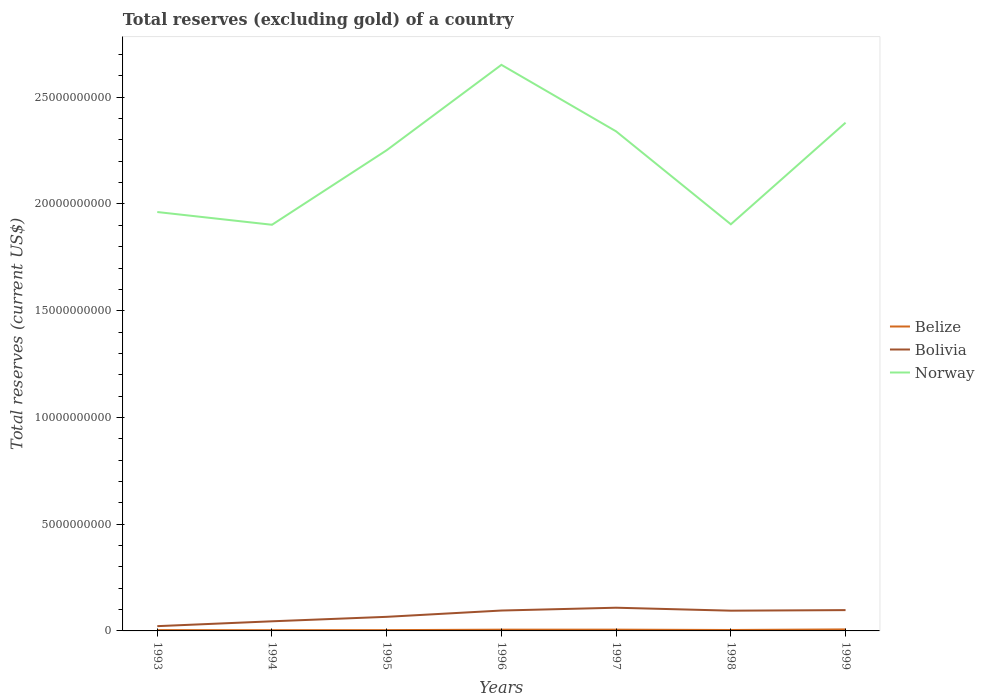Does the line corresponding to Belize intersect with the line corresponding to Bolivia?
Your answer should be very brief. No. Is the number of lines equal to the number of legend labels?
Offer a very short reply. Yes. Across all years, what is the maximum total reserves (excluding gold) in Belize?
Provide a succinct answer. 3.45e+07. What is the total total reserves (excluding gold) in Norway in the graph?
Provide a short and direct response. -8.83e+08. What is the difference between the highest and the second highest total reserves (excluding gold) in Norway?
Offer a very short reply. 7.49e+09. Is the total reserves (excluding gold) in Bolivia strictly greater than the total reserves (excluding gold) in Norway over the years?
Your answer should be very brief. Yes. What is the difference between two consecutive major ticks on the Y-axis?
Make the answer very short. 5.00e+09. How many legend labels are there?
Make the answer very short. 3. How are the legend labels stacked?
Give a very brief answer. Vertical. What is the title of the graph?
Give a very brief answer. Total reserves (excluding gold) of a country. What is the label or title of the Y-axis?
Give a very brief answer. Total reserves (current US$). What is the Total reserves (current US$) in Belize in 1993?
Keep it short and to the point. 3.87e+07. What is the Total reserves (current US$) in Bolivia in 1993?
Keep it short and to the point. 2.23e+08. What is the Total reserves (current US$) of Norway in 1993?
Provide a succinct answer. 1.96e+1. What is the Total reserves (current US$) in Belize in 1994?
Provide a succinct answer. 3.45e+07. What is the Total reserves (current US$) in Bolivia in 1994?
Make the answer very short. 4.51e+08. What is the Total reserves (current US$) of Norway in 1994?
Your answer should be very brief. 1.90e+1. What is the Total reserves (current US$) of Belize in 1995?
Ensure brevity in your answer.  3.76e+07. What is the Total reserves (current US$) of Bolivia in 1995?
Offer a very short reply. 6.60e+08. What is the Total reserves (current US$) in Norway in 1995?
Keep it short and to the point. 2.25e+1. What is the Total reserves (current US$) of Belize in 1996?
Provide a succinct answer. 5.84e+07. What is the Total reserves (current US$) in Bolivia in 1996?
Ensure brevity in your answer.  9.55e+08. What is the Total reserves (current US$) of Norway in 1996?
Offer a terse response. 2.65e+1. What is the Total reserves (current US$) in Belize in 1997?
Provide a short and direct response. 5.94e+07. What is the Total reserves (current US$) in Bolivia in 1997?
Your response must be concise. 1.09e+09. What is the Total reserves (current US$) in Norway in 1997?
Your answer should be compact. 2.34e+1. What is the Total reserves (current US$) in Belize in 1998?
Your answer should be very brief. 4.41e+07. What is the Total reserves (current US$) of Bolivia in 1998?
Offer a very short reply. 9.48e+08. What is the Total reserves (current US$) in Norway in 1998?
Ensure brevity in your answer.  1.90e+1. What is the Total reserves (current US$) in Belize in 1999?
Your answer should be compact. 7.13e+07. What is the Total reserves (current US$) in Bolivia in 1999?
Provide a succinct answer. 9.75e+08. What is the Total reserves (current US$) of Norway in 1999?
Make the answer very short. 2.38e+1. Across all years, what is the maximum Total reserves (current US$) of Belize?
Your answer should be compact. 7.13e+07. Across all years, what is the maximum Total reserves (current US$) of Bolivia?
Make the answer very short. 1.09e+09. Across all years, what is the maximum Total reserves (current US$) in Norway?
Make the answer very short. 2.65e+1. Across all years, what is the minimum Total reserves (current US$) in Belize?
Ensure brevity in your answer.  3.45e+07. Across all years, what is the minimum Total reserves (current US$) of Bolivia?
Offer a very short reply. 2.23e+08. Across all years, what is the minimum Total reserves (current US$) in Norway?
Offer a terse response. 1.90e+1. What is the total Total reserves (current US$) of Belize in the graph?
Provide a short and direct response. 3.44e+08. What is the total Total reserves (current US$) in Bolivia in the graph?
Your answer should be compact. 5.30e+09. What is the total Total reserves (current US$) in Norway in the graph?
Provide a short and direct response. 1.54e+11. What is the difference between the Total reserves (current US$) of Belize in 1993 and that in 1994?
Provide a succinct answer. 4.22e+06. What is the difference between the Total reserves (current US$) in Bolivia in 1993 and that in 1994?
Your response must be concise. -2.28e+08. What is the difference between the Total reserves (current US$) of Norway in 1993 and that in 1994?
Provide a succinct answer. 5.97e+08. What is the difference between the Total reserves (current US$) in Belize in 1993 and that in 1995?
Provide a succinct answer. 1.14e+06. What is the difference between the Total reserves (current US$) in Bolivia in 1993 and that in 1995?
Your response must be concise. -4.37e+08. What is the difference between the Total reserves (current US$) of Norway in 1993 and that in 1995?
Your answer should be compact. -2.90e+09. What is the difference between the Total reserves (current US$) in Belize in 1993 and that in 1996?
Keep it short and to the point. -1.97e+07. What is the difference between the Total reserves (current US$) in Bolivia in 1993 and that in 1996?
Give a very brief answer. -7.32e+08. What is the difference between the Total reserves (current US$) of Norway in 1993 and that in 1996?
Make the answer very short. -6.89e+09. What is the difference between the Total reserves (current US$) of Belize in 1993 and that in 1997?
Offer a terse response. -2.07e+07. What is the difference between the Total reserves (current US$) in Bolivia in 1993 and that in 1997?
Offer a terse response. -8.63e+08. What is the difference between the Total reserves (current US$) of Norway in 1993 and that in 1997?
Your answer should be compact. -3.78e+09. What is the difference between the Total reserves (current US$) in Belize in 1993 and that in 1998?
Provide a succinct answer. -5.34e+06. What is the difference between the Total reserves (current US$) in Bolivia in 1993 and that in 1998?
Keep it short and to the point. -7.25e+08. What is the difference between the Total reserves (current US$) in Norway in 1993 and that in 1998?
Ensure brevity in your answer.  5.74e+08. What is the difference between the Total reserves (current US$) in Belize in 1993 and that in 1999?
Your answer should be compact. -3.26e+07. What is the difference between the Total reserves (current US$) of Bolivia in 1993 and that in 1999?
Your answer should be compact. -7.52e+08. What is the difference between the Total reserves (current US$) in Norway in 1993 and that in 1999?
Give a very brief answer. -4.18e+09. What is the difference between the Total reserves (current US$) of Belize in 1994 and that in 1995?
Provide a succinct answer. -3.09e+06. What is the difference between the Total reserves (current US$) in Bolivia in 1994 and that in 1995?
Your answer should be very brief. -2.09e+08. What is the difference between the Total reserves (current US$) of Norway in 1994 and that in 1995?
Give a very brief answer. -3.49e+09. What is the difference between the Total reserves (current US$) of Belize in 1994 and that in 1996?
Offer a very short reply. -2.39e+07. What is the difference between the Total reserves (current US$) in Bolivia in 1994 and that in 1996?
Your answer should be very brief. -5.04e+08. What is the difference between the Total reserves (current US$) in Norway in 1994 and that in 1996?
Make the answer very short. -7.49e+09. What is the difference between the Total reserves (current US$) in Belize in 1994 and that in 1997?
Keep it short and to the point. -2.49e+07. What is the difference between the Total reserves (current US$) of Bolivia in 1994 and that in 1997?
Offer a very short reply. -6.36e+08. What is the difference between the Total reserves (current US$) of Norway in 1994 and that in 1997?
Provide a short and direct response. -4.37e+09. What is the difference between the Total reserves (current US$) of Belize in 1994 and that in 1998?
Your response must be concise. -9.56e+06. What is the difference between the Total reserves (current US$) of Bolivia in 1994 and that in 1998?
Your response must be concise. -4.98e+08. What is the difference between the Total reserves (current US$) in Norway in 1994 and that in 1998?
Offer a very short reply. -2.26e+07. What is the difference between the Total reserves (current US$) in Belize in 1994 and that in 1999?
Offer a very short reply. -3.68e+07. What is the difference between the Total reserves (current US$) in Bolivia in 1994 and that in 1999?
Make the answer very short. -5.24e+08. What is the difference between the Total reserves (current US$) of Norway in 1994 and that in 1999?
Ensure brevity in your answer.  -4.78e+09. What is the difference between the Total reserves (current US$) in Belize in 1995 and that in 1996?
Your answer should be compact. -2.08e+07. What is the difference between the Total reserves (current US$) of Bolivia in 1995 and that in 1996?
Give a very brief answer. -2.95e+08. What is the difference between the Total reserves (current US$) of Norway in 1995 and that in 1996?
Make the answer very short. -4.00e+09. What is the difference between the Total reserves (current US$) in Belize in 1995 and that in 1997?
Your answer should be compact. -2.18e+07. What is the difference between the Total reserves (current US$) in Bolivia in 1995 and that in 1997?
Your response must be concise. -4.27e+08. What is the difference between the Total reserves (current US$) in Norway in 1995 and that in 1997?
Your response must be concise. -8.83e+08. What is the difference between the Total reserves (current US$) in Belize in 1995 and that in 1998?
Ensure brevity in your answer.  -6.48e+06. What is the difference between the Total reserves (current US$) of Bolivia in 1995 and that in 1998?
Your answer should be compact. -2.89e+08. What is the difference between the Total reserves (current US$) of Norway in 1995 and that in 1998?
Your answer should be compact. 3.47e+09. What is the difference between the Total reserves (current US$) in Belize in 1995 and that in 1999?
Offer a terse response. -3.37e+07. What is the difference between the Total reserves (current US$) in Bolivia in 1995 and that in 1999?
Provide a short and direct response. -3.15e+08. What is the difference between the Total reserves (current US$) of Norway in 1995 and that in 1999?
Provide a succinct answer. -1.29e+09. What is the difference between the Total reserves (current US$) of Belize in 1996 and that in 1997?
Give a very brief answer. -1.01e+06. What is the difference between the Total reserves (current US$) of Bolivia in 1996 and that in 1997?
Give a very brief answer. -1.32e+08. What is the difference between the Total reserves (current US$) in Norway in 1996 and that in 1997?
Provide a succinct answer. 3.12e+09. What is the difference between the Total reserves (current US$) of Belize in 1996 and that in 1998?
Your response must be concise. 1.43e+07. What is the difference between the Total reserves (current US$) of Bolivia in 1996 and that in 1998?
Make the answer very short. 6.52e+06. What is the difference between the Total reserves (current US$) of Norway in 1996 and that in 1998?
Keep it short and to the point. 7.47e+09. What is the difference between the Total reserves (current US$) of Belize in 1996 and that in 1999?
Your response must be concise. -1.29e+07. What is the difference between the Total reserves (current US$) in Bolivia in 1996 and that in 1999?
Your answer should be very brief. -1.99e+07. What is the difference between the Total reserves (current US$) of Norway in 1996 and that in 1999?
Your response must be concise. 2.71e+09. What is the difference between the Total reserves (current US$) of Belize in 1997 and that in 1998?
Provide a succinct answer. 1.53e+07. What is the difference between the Total reserves (current US$) in Bolivia in 1997 and that in 1998?
Your answer should be very brief. 1.38e+08. What is the difference between the Total reserves (current US$) in Norway in 1997 and that in 1998?
Your response must be concise. 4.35e+09. What is the difference between the Total reserves (current US$) of Belize in 1997 and that in 1999?
Your response must be concise. -1.19e+07. What is the difference between the Total reserves (current US$) in Bolivia in 1997 and that in 1999?
Offer a terse response. 1.12e+08. What is the difference between the Total reserves (current US$) in Norway in 1997 and that in 1999?
Give a very brief answer. -4.07e+08. What is the difference between the Total reserves (current US$) in Belize in 1998 and that in 1999?
Offer a terse response. -2.72e+07. What is the difference between the Total reserves (current US$) of Bolivia in 1998 and that in 1999?
Make the answer very short. -2.64e+07. What is the difference between the Total reserves (current US$) of Norway in 1998 and that in 1999?
Your answer should be compact. -4.76e+09. What is the difference between the Total reserves (current US$) in Belize in 1993 and the Total reserves (current US$) in Bolivia in 1994?
Make the answer very short. -4.12e+08. What is the difference between the Total reserves (current US$) in Belize in 1993 and the Total reserves (current US$) in Norway in 1994?
Keep it short and to the point. -1.90e+1. What is the difference between the Total reserves (current US$) of Bolivia in 1993 and the Total reserves (current US$) of Norway in 1994?
Your answer should be compact. -1.88e+1. What is the difference between the Total reserves (current US$) in Belize in 1993 and the Total reserves (current US$) in Bolivia in 1995?
Offer a terse response. -6.21e+08. What is the difference between the Total reserves (current US$) in Belize in 1993 and the Total reserves (current US$) in Norway in 1995?
Offer a very short reply. -2.25e+1. What is the difference between the Total reserves (current US$) of Bolivia in 1993 and the Total reserves (current US$) of Norway in 1995?
Provide a succinct answer. -2.23e+1. What is the difference between the Total reserves (current US$) of Belize in 1993 and the Total reserves (current US$) of Bolivia in 1996?
Make the answer very short. -9.16e+08. What is the difference between the Total reserves (current US$) in Belize in 1993 and the Total reserves (current US$) in Norway in 1996?
Your response must be concise. -2.65e+1. What is the difference between the Total reserves (current US$) in Bolivia in 1993 and the Total reserves (current US$) in Norway in 1996?
Your answer should be very brief. -2.63e+1. What is the difference between the Total reserves (current US$) in Belize in 1993 and the Total reserves (current US$) in Bolivia in 1997?
Provide a short and direct response. -1.05e+09. What is the difference between the Total reserves (current US$) of Belize in 1993 and the Total reserves (current US$) of Norway in 1997?
Ensure brevity in your answer.  -2.34e+1. What is the difference between the Total reserves (current US$) in Bolivia in 1993 and the Total reserves (current US$) in Norway in 1997?
Ensure brevity in your answer.  -2.32e+1. What is the difference between the Total reserves (current US$) in Belize in 1993 and the Total reserves (current US$) in Bolivia in 1998?
Your answer should be compact. -9.10e+08. What is the difference between the Total reserves (current US$) of Belize in 1993 and the Total reserves (current US$) of Norway in 1998?
Give a very brief answer. -1.90e+1. What is the difference between the Total reserves (current US$) in Bolivia in 1993 and the Total reserves (current US$) in Norway in 1998?
Your answer should be very brief. -1.88e+1. What is the difference between the Total reserves (current US$) in Belize in 1993 and the Total reserves (current US$) in Bolivia in 1999?
Make the answer very short. -9.36e+08. What is the difference between the Total reserves (current US$) in Belize in 1993 and the Total reserves (current US$) in Norway in 1999?
Your response must be concise. -2.38e+1. What is the difference between the Total reserves (current US$) of Bolivia in 1993 and the Total reserves (current US$) of Norway in 1999?
Your answer should be compact. -2.36e+1. What is the difference between the Total reserves (current US$) of Belize in 1994 and the Total reserves (current US$) of Bolivia in 1995?
Offer a very short reply. -6.25e+08. What is the difference between the Total reserves (current US$) of Belize in 1994 and the Total reserves (current US$) of Norway in 1995?
Offer a terse response. -2.25e+1. What is the difference between the Total reserves (current US$) in Bolivia in 1994 and the Total reserves (current US$) in Norway in 1995?
Offer a terse response. -2.21e+1. What is the difference between the Total reserves (current US$) in Belize in 1994 and the Total reserves (current US$) in Bolivia in 1996?
Provide a short and direct response. -9.20e+08. What is the difference between the Total reserves (current US$) in Belize in 1994 and the Total reserves (current US$) in Norway in 1996?
Ensure brevity in your answer.  -2.65e+1. What is the difference between the Total reserves (current US$) in Bolivia in 1994 and the Total reserves (current US$) in Norway in 1996?
Provide a succinct answer. -2.61e+1. What is the difference between the Total reserves (current US$) of Belize in 1994 and the Total reserves (current US$) of Bolivia in 1997?
Offer a terse response. -1.05e+09. What is the difference between the Total reserves (current US$) in Belize in 1994 and the Total reserves (current US$) in Norway in 1997?
Your answer should be very brief. -2.34e+1. What is the difference between the Total reserves (current US$) in Bolivia in 1994 and the Total reserves (current US$) in Norway in 1997?
Give a very brief answer. -2.29e+1. What is the difference between the Total reserves (current US$) in Belize in 1994 and the Total reserves (current US$) in Bolivia in 1998?
Give a very brief answer. -9.14e+08. What is the difference between the Total reserves (current US$) of Belize in 1994 and the Total reserves (current US$) of Norway in 1998?
Provide a succinct answer. -1.90e+1. What is the difference between the Total reserves (current US$) in Bolivia in 1994 and the Total reserves (current US$) in Norway in 1998?
Keep it short and to the point. -1.86e+1. What is the difference between the Total reserves (current US$) in Belize in 1994 and the Total reserves (current US$) in Bolivia in 1999?
Provide a succinct answer. -9.40e+08. What is the difference between the Total reserves (current US$) in Belize in 1994 and the Total reserves (current US$) in Norway in 1999?
Your answer should be very brief. -2.38e+1. What is the difference between the Total reserves (current US$) of Bolivia in 1994 and the Total reserves (current US$) of Norway in 1999?
Your response must be concise. -2.34e+1. What is the difference between the Total reserves (current US$) in Belize in 1995 and the Total reserves (current US$) in Bolivia in 1996?
Offer a very short reply. -9.17e+08. What is the difference between the Total reserves (current US$) in Belize in 1995 and the Total reserves (current US$) in Norway in 1996?
Provide a succinct answer. -2.65e+1. What is the difference between the Total reserves (current US$) in Bolivia in 1995 and the Total reserves (current US$) in Norway in 1996?
Your response must be concise. -2.59e+1. What is the difference between the Total reserves (current US$) of Belize in 1995 and the Total reserves (current US$) of Bolivia in 1997?
Your answer should be compact. -1.05e+09. What is the difference between the Total reserves (current US$) in Belize in 1995 and the Total reserves (current US$) in Norway in 1997?
Give a very brief answer. -2.34e+1. What is the difference between the Total reserves (current US$) of Bolivia in 1995 and the Total reserves (current US$) of Norway in 1997?
Provide a short and direct response. -2.27e+1. What is the difference between the Total reserves (current US$) of Belize in 1995 and the Total reserves (current US$) of Bolivia in 1998?
Give a very brief answer. -9.11e+08. What is the difference between the Total reserves (current US$) in Belize in 1995 and the Total reserves (current US$) in Norway in 1998?
Your answer should be compact. -1.90e+1. What is the difference between the Total reserves (current US$) in Bolivia in 1995 and the Total reserves (current US$) in Norway in 1998?
Your response must be concise. -1.84e+1. What is the difference between the Total reserves (current US$) in Belize in 1995 and the Total reserves (current US$) in Bolivia in 1999?
Your answer should be very brief. -9.37e+08. What is the difference between the Total reserves (current US$) of Belize in 1995 and the Total reserves (current US$) of Norway in 1999?
Keep it short and to the point. -2.38e+1. What is the difference between the Total reserves (current US$) of Bolivia in 1995 and the Total reserves (current US$) of Norway in 1999?
Ensure brevity in your answer.  -2.31e+1. What is the difference between the Total reserves (current US$) in Belize in 1996 and the Total reserves (current US$) in Bolivia in 1997?
Give a very brief answer. -1.03e+09. What is the difference between the Total reserves (current US$) of Belize in 1996 and the Total reserves (current US$) of Norway in 1997?
Your response must be concise. -2.33e+1. What is the difference between the Total reserves (current US$) in Bolivia in 1996 and the Total reserves (current US$) in Norway in 1997?
Offer a terse response. -2.24e+1. What is the difference between the Total reserves (current US$) in Belize in 1996 and the Total reserves (current US$) in Bolivia in 1998?
Your answer should be very brief. -8.90e+08. What is the difference between the Total reserves (current US$) of Belize in 1996 and the Total reserves (current US$) of Norway in 1998?
Offer a very short reply. -1.90e+1. What is the difference between the Total reserves (current US$) of Bolivia in 1996 and the Total reserves (current US$) of Norway in 1998?
Provide a short and direct response. -1.81e+1. What is the difference between the Total reserves (current US$) in Belize in 1996 and the Total reserves (current US$) in Bolivia in 1999?
Your response must be concise. -9.17e+08. What is the difference between the Total reserves (current US$) of Belize in 1996 and the Total reserves (current US$) of Norway in 1999?
Make the answer very short. -2.37e+1. What is the difference between the Total reserves (current US$) of Bolivia in 1996 and the Total reserves (current US$) of Norway in 1999?
Offer a very short reply. -2.29e+1. What is the difference between the Total reserves (current US$) of Belize in 1997 and the Total reserves (current US$) of Bolivia in 1998?
Offer a terse response. -8.89e+08. What is the difference between the Total reserves (current US$) of Belize in 1997 and the Total reserves (current US$) of Norway in 1998?
Provide a short and direct response. -1.90e+1. What is the difference between the Total reserves (current US$) of Bolivia in 1997 and the Total reserves (current US$) of Norway in 1998?
Your answer should be very brief. -1.80e+1. What is the difference between the Total reserves (current US$) in Belize in 1997 and the Total reserves (current US$) in Bolivia in 1999?
Offer a very short reply. -9.16e+08. What is the difference between the Total reserves (current US$) in Belize in 1997 and the Total reserves (current US$) in Norway in 1999?
Offer a very short reply. -2.37e+1. What is the difference between the Total reserves (current US$) of Bolivia in 1997 and the Total reserves (current US$) of Norway in 1999?
Offer a terse response. -2.27e+1. What is the difference between the Total reserves (current US$) in Belize in 1998 and the Total reserves (current US$) in Bolivia in 1999?
Offer a terse response. -9.31e+08. What is the difference between the Total reserves (current US$) of Belize in 1998 and the Total reserves (current US$) of Norway in 1999?
Give a very brief answer. -2.38e+1. What is the difference between the Total reserves (current US$) of Bolivia in 1998 and the Total reserves (current US$) of Norway in 1999?
Your answer should be compact. -2.29e+1. What is the average Total reserves (current US$) of Belize per year?
Offer a very short reply. 4.92e+07. What is the average Total reserves (current US$) in Bolivia per year?
Your answer should be very brief. 7.57e+08. What is the average Total reserves (current US$) in Norway per year?
Your answer should be compact. 2.20e+1. In the year 1993, what is the difference between the Total reserves (current US$) in Belize and Total reserves (current US$) in Bolivia?
Your response must be concise. -1.85e+08. In the year 1993, what is the difference between the Total reserves (current US$) of Belize and Total reserves (current US$) of Norway?
Provide a succinct answer. -1.96e+1. In the year 1993, what is the difference between the Total reserves (current US$) of Bolivia and Total reserves (current US$) of Norway?
Provide a succinct answer. -1.94e+1. In the year 1994, what is the difference between the Total reserves (current US$) in Belize and Total reserves (current US$) in Bolivia?
Give a very brief answer. -4.16e+08. In the year 1994, what is the difference between the Total reserves (current US$) of Belize and Total reserves (current US$) of Norway?
Offer a very short reply. -1.90e+1. In the year 1994, what is the difference between the Total reserves (current US$) of Bolivia and Total reserves (current US$) of Norway?
Offer a terse response. -1.86e+1. In the year 1995, what is the difference between the Total reserves (current US$) of Belize and Total reserves (current US$) of Bolivia?
Provide a succinct answer. -6.22e+08. In the year 1995, what is the difference between the Total reserves (current US$) in Belize and Total reserves (current US$) in Norway?
Your response must be concise. -2.25e+1. In the year 1995, what is the difference between the Total reserves (current US$) of Bolivia and Total reserves (current US$) of Norway?
Your answer should be compact. -2.19e+1. In the year 1996, what is the difference between the Total reserves (current US$) in Belize and Total reserves (current US$) in Bolivia?
Offer a very short reply. -8.97e+08. In the year 1996, what is the difference between the Total reserves (current US$) of Belize and Total reserves (current US$) of Norway?
Offer a very short reply. -2.65e+1. In the year 1996, what is the difference between the Total reserves (current US$) in Bolivia and Total reserves (current US$) in Norway?
Keep it short and to the point. -2.56e+1. In the year 1997, what is the difference between the Total reserves (current US$) in Belize and Total reserves (current US$) in Bolivia?
Give a very brief answer. -1.03e+09. In the year 1997, what is the difference between the Total reserves (current US$) in Belize and Total reserves (current US$) in Norway?
Give a very brief answer. -2.33e+1. In the year 1997, what is the difference between the Total reserves (current US$) of Bolivia and Total reserves (current US$) of Norway?
Your answer should be compact. -2.23e+1. In the year 1998, what is the difference between the Total reserves (current US$) in Belize and Total reserves (current US$) in Bolivia?
Make the answer very short. -9.04e+08. In the year 1998, what is the difference between the Total reserves (current US$) of Belize and Total reserves (current US$) of Norway?
Your response must be concise. -1.90e+1. In the year 1998, what is the difference between the Total reserves (current US$) in Bolivia and Total reserves (current US$) in Norway?
Provide a short and direct response. -1.81e+1. In the year 1999, what is the difference between the Total reserves (current US$) in Belize and Total reserves (current US$) in Bolivia?
Give a very brief answer. -9.04e+08. In the year 1999, what is the difference between the Total reserves (current US$) of Belize and Total reserves (current US$) of Norway?
Provide a succinct answer. -2.37e+1. In the year 1999, what is the difference between the Total reserves (current US$) of Bolivia and Total reserves (current US$) of Norway?
Keep it short and to the point. -2.28e+1. What is the ratio of the Total reserves (current US$) in Belize in 1993 to that in 1994?
Provide a succinct answer. 1.12. What is the ratio of the Total reserves (current US$) in Bolivia in 1993 to that in 1994?
Provide a short and direct response. 0.5. What is the ratio of the Total reserves (current US$) of Norway in 1993 to that in 1994?
Your response must be concise. 1.03. What is the ratio of the Total reserves (current US$) of Belize in 1993 to that in 1995?
Offer a very short reply. 1.03. What is the ratio of the Total reserves (current US$) in Bolivia in 1993 to that in 1995?
Provide a short and direct response. 0.34. What is the ratio of the Total reserves (current US$) of Norway in 1993 to that in 1995?
Your response must be concise. 0.87. What is the ratio of the Total reserves (current US$) of Belize in 1993 to that in 1996?
Your response must be concise. 0.66. What is the ratio of the Total reserves (current US$) of Bolivia in 1993 to that in 1996?
Ensure brevity in your answer.  0.23. What is the ratio of the Total reserves (current US$) in Norway in 1993 to that in 1996?
Provide a short and direct response. 0.74. What is the ratio of the Total reserves (current US$) in Belize in 1993 to that in 1997?
Offer a terse response. 0.65. What is the ratio of the Total reserves (current US$) of Bolivia in 1993 to that in 1997?
Offer a very short reply. 0.21. What is the ratio of the Total reserves (current US$) in Norway in 1993 to that in 1997?
Keep it short and to the point. 0.84. What is the ratio of the Total reserves (current US$) in Belize in 1993 to that in 1998?
Your response must be concise. 0.88. What is the ratio of the Total reserves (current US$) in Bolivia in 1993 to that in 1998?
Offer a terse response. 0.24. What is the ratio of the Total reserves (current US$) in Norway in 1993 to that in 1998?
Provide a succinct answer. 1.03. What is the ratio of the Total reserves (current US$) of Belize in 1993 to that in 1999?
Your answer should be compact. 0.54. What is the ratio of the Total reserves (current US$) of Bolivia in 1993 to that in 1999?
Your answer should be very brief. 0.23. What is the ratio of the Total reserves (current US$) of Norway in 1993 to that in 1999?
Your answer should be very brief. 0.82. What is the ratio of the Total reserves (current US$) in Belize in 1994 to that in 1995?
Offer a terse response. 0.92. What is the ratio of the Total reserves (current US$) in Bolivia in 1994 to that in 1995?
Your answer should be compact. 0.68. What is the ratio of the Total reserves (current US$) in Norway in 1994 to that in 1995?
Your response must be concise. 0.84. What is the ratio of the Total reserves (current US$) of Belize in 1994 to that in 1996?
Ensure brevity in your answer.  0.59. What is the ratio of the Total reserves (current US$) in Bolivia in 1994 to that in 1996?
Offer a very short reply. 0.47. What is the ratio of the Total reserves (current US$) in Norway in 1994 to that in 1996?
Ensure brevity in your answer.  0.72. What is the ratio of the Total reserves (current US$) in Belize in 1994 to that in 1997?
Ensure brevity in your answer.  0.58. What is the ratio of the Total reserves (current US$) in Bolivia in 1994 to that in 1997?
Provide a short and direct response. 0.41. What is the ratio of the Total reserves (current US$) in Norway in 1994 to that in 1997?
Your answer should be compact. 0.81. What is the ratio of the Total reserves (current US$) in Belize in 1994 to that in 1998?
Keep it short and to the point. 0.78. What is the ratio of the Total reserves (current US$) in Bolivia in 1994 to that in 1998?
Offer a very short reply. 0.48. What is the ratio of the Total reserves (current US$) of Norway in 1994 to that in 1998?
Give a very brief answer. 1. What is the ratio of the Total reserves (current US$) in Belize in 1994 to that in 1999?
Offer a very short reply. 0.48. What is the ratio of the Total reserves (current US$) in Bolivia in 1994 to that in 1999?
Your response must be concise. 0.46. What is the ratio of the Total reserves (current US$) of Norway in 1994 to that in 1999?
Make the answer very short. 0.8. What is the ratio of the Total reserves (current US$) of Belize in 1995 to that in 1996?
Ensure brevity in your answer.  0.64. What is the ratio of the Total reserves (current US$) of Bolivia in 1995 to that in 1996?
Give a very brief answer. 0.69. What is the ratio of the Total reserves (current US$) of Norway in 1995 to that in 1996?
Keep it short and to the point. 0.85. What is the ratio of the Total reserves (current US$) in Belize in 1995 to that in 1997?
Ensure brevity in your answer.  0.63. What is the ratio of the Total reserves (current US$) in Bolivia in 1995 to that in 1997?
Your answer should be compact. 0.61. What is the ratio of the Total reserves (current US$) of Norway in 1995 to that in 1997?
Offer a terse response. 0.96. What is the ratio of the Total reserves (current US$) of Belize in 1995 to that in 1998?
Give a very brief answer. 0.85. What is the ratio of the Total reserves (current US$) in Bolivia in 1995 to that in 1998?
Provide a succinct answer. 0.7. What is the ratio of the Total reserves (current US$) of Norway in 1995 to that in 1998?
Your answer should be very brief. 1.18. What is the ratio of the Total reserves (current US$) of Belize in 1995 to that in 1999?
Your answer should be very brief. 0.53. What is the ratio of the Total reserves (current US$) in Bolivia in 1995 to that in 1999?
Your response must be concise. 0.68. What is the ratio of the Total reserves (current US$) of Norway in 1995 to that in 1999?
Offer a very short reply. 0.95. What is the ratio of the Total reserves (current US$) of Belize in 1996 to that in 1997?
Ensure brevity in your answer.  0.98. What is the ratio of the Total reserves (current US$) in Bolivia in 1996 to that in 1997?
Provide a succinct answer. 0.88. What is the ratio of the Total reserves (current US$) in Norway in 1996 to that in 1997?
Make the answer very short. 1.13. What is the ratio of the Total reserves (current US$) in Belize in 1996 to that in 1998?
Ensure brevity in your answer.  1.32. What is the ratio of the Total reserves (current US$) in Norway in 1996 to that in 1998?
Keep it short and to the point. 1.39. What is the ratio of the Total reserves (current US$) of Belize in 1996 to that in 1999?
Offer a terse response. 0.82. What is the ratio of the Total reserves (current US$) of Bolivia in 1996 to that in 1999?
Offer a terse response. 0.98. What is the ratio of the Total reserves (current US$) in Norway in 1996 to that in 1999?
Your answer should be very brief. 1.11. What is the ratio of the Total reserves (current US$) of Belize in 1997 to that in 1998?
Keep it short and to the point. 1.35. What is the ratio of the Total reserves (current US$) of Bolivia in 1997 to that in 1998?
Your response must be concise. 1.15. What is the ratio of the Total reserves (current US$) in Norway in 1997 to that in 1998?
Your answer should be very brief. 1.23. What is the ratio of the Total reserves (current US$) of Belize in 1997 to that in 1999?
Keep it short and to the point. 0.83. What is the ratio of the Total reserves (current US$) in Bolivia in 1997 to that in 1999?
Your response must be concise. 1.11. What is the ratio of the Total reserves (current US$) in Norway in 1997 to that in 1999?
Ensure brevity in your answer.  0.98. What is the ratio of the Total reserves (current US$) of Belize in 1998 to that in 1999?
Provide a short and direct response. 0.62. What is the ratio of the Total reserves (current US$) of Bolivia in 1998 to that in 1999?
Offer a very short reply. 0.97. What is the ratio of the Total reserves (current US$) of Norway in 1998 to that in 1999?
Your answer should be compact. 0.8. What is the difference between the highest and the second highest Total reserves (current US$) of Belize?
Your answer should be compact. 1.19e+07. What is the difference between the highest and the second highest Total reserves (current US$) in Bolivia?
Give a very brief answer. 1.12e+08. What is the difference between the highest and the second highest Total reserves (current US$) in Norway?
Provide a succinct answer. 2.71e+09. What is the difference between the highest and the lowest Total reserves (current US$) of Belize?
Offer a very short reply. 3.68e+07. What is the difference between the highest and the lowest Total reserves (current US$) in Bolivia?
Ensure brevity in your answer.  8.63e+08. What is the difference between the highest and the lowest Total reserves (current US$) of Norway?
Offer a terse response. 7.49e+09. 